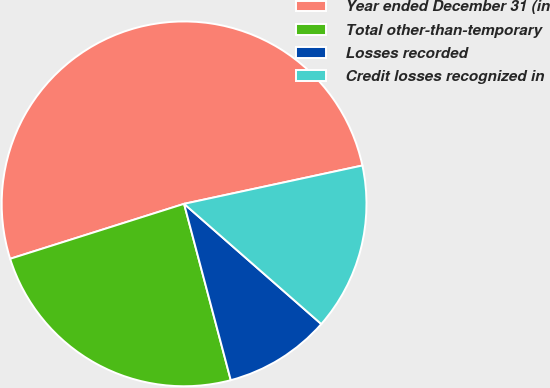<chart> <loc_0><loc_0><loc_500><loc_500><pie_chart><fcel>Year ended December 31 (in<fcel>Total other-than-temporary<fcel>Losses recorded<fcel>Credit losses recognized in<nl><fcel>51.5%<fcel>24.25%<fcel>9.43%<fcel>14.82%<nl></chart> 